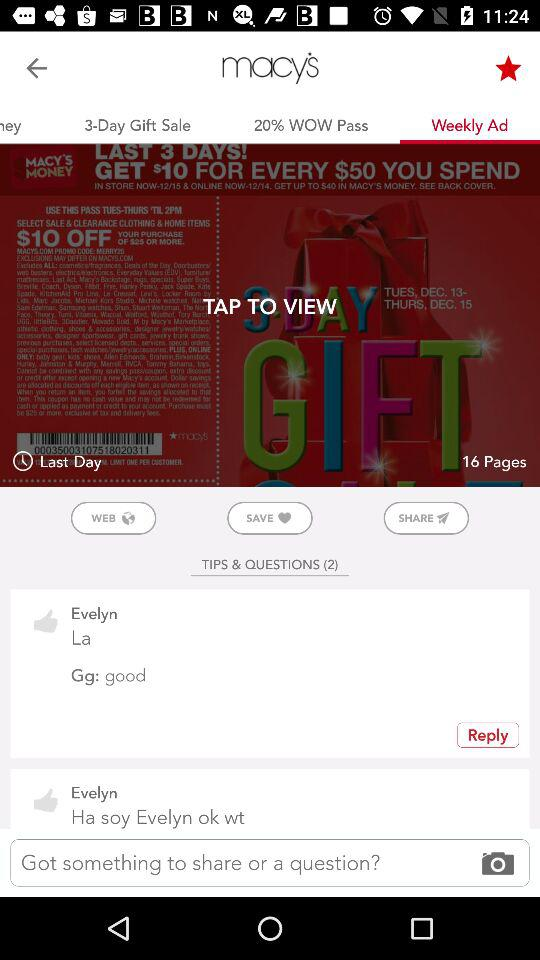Which option has been selected? The selected option is "Weekly Ad". 